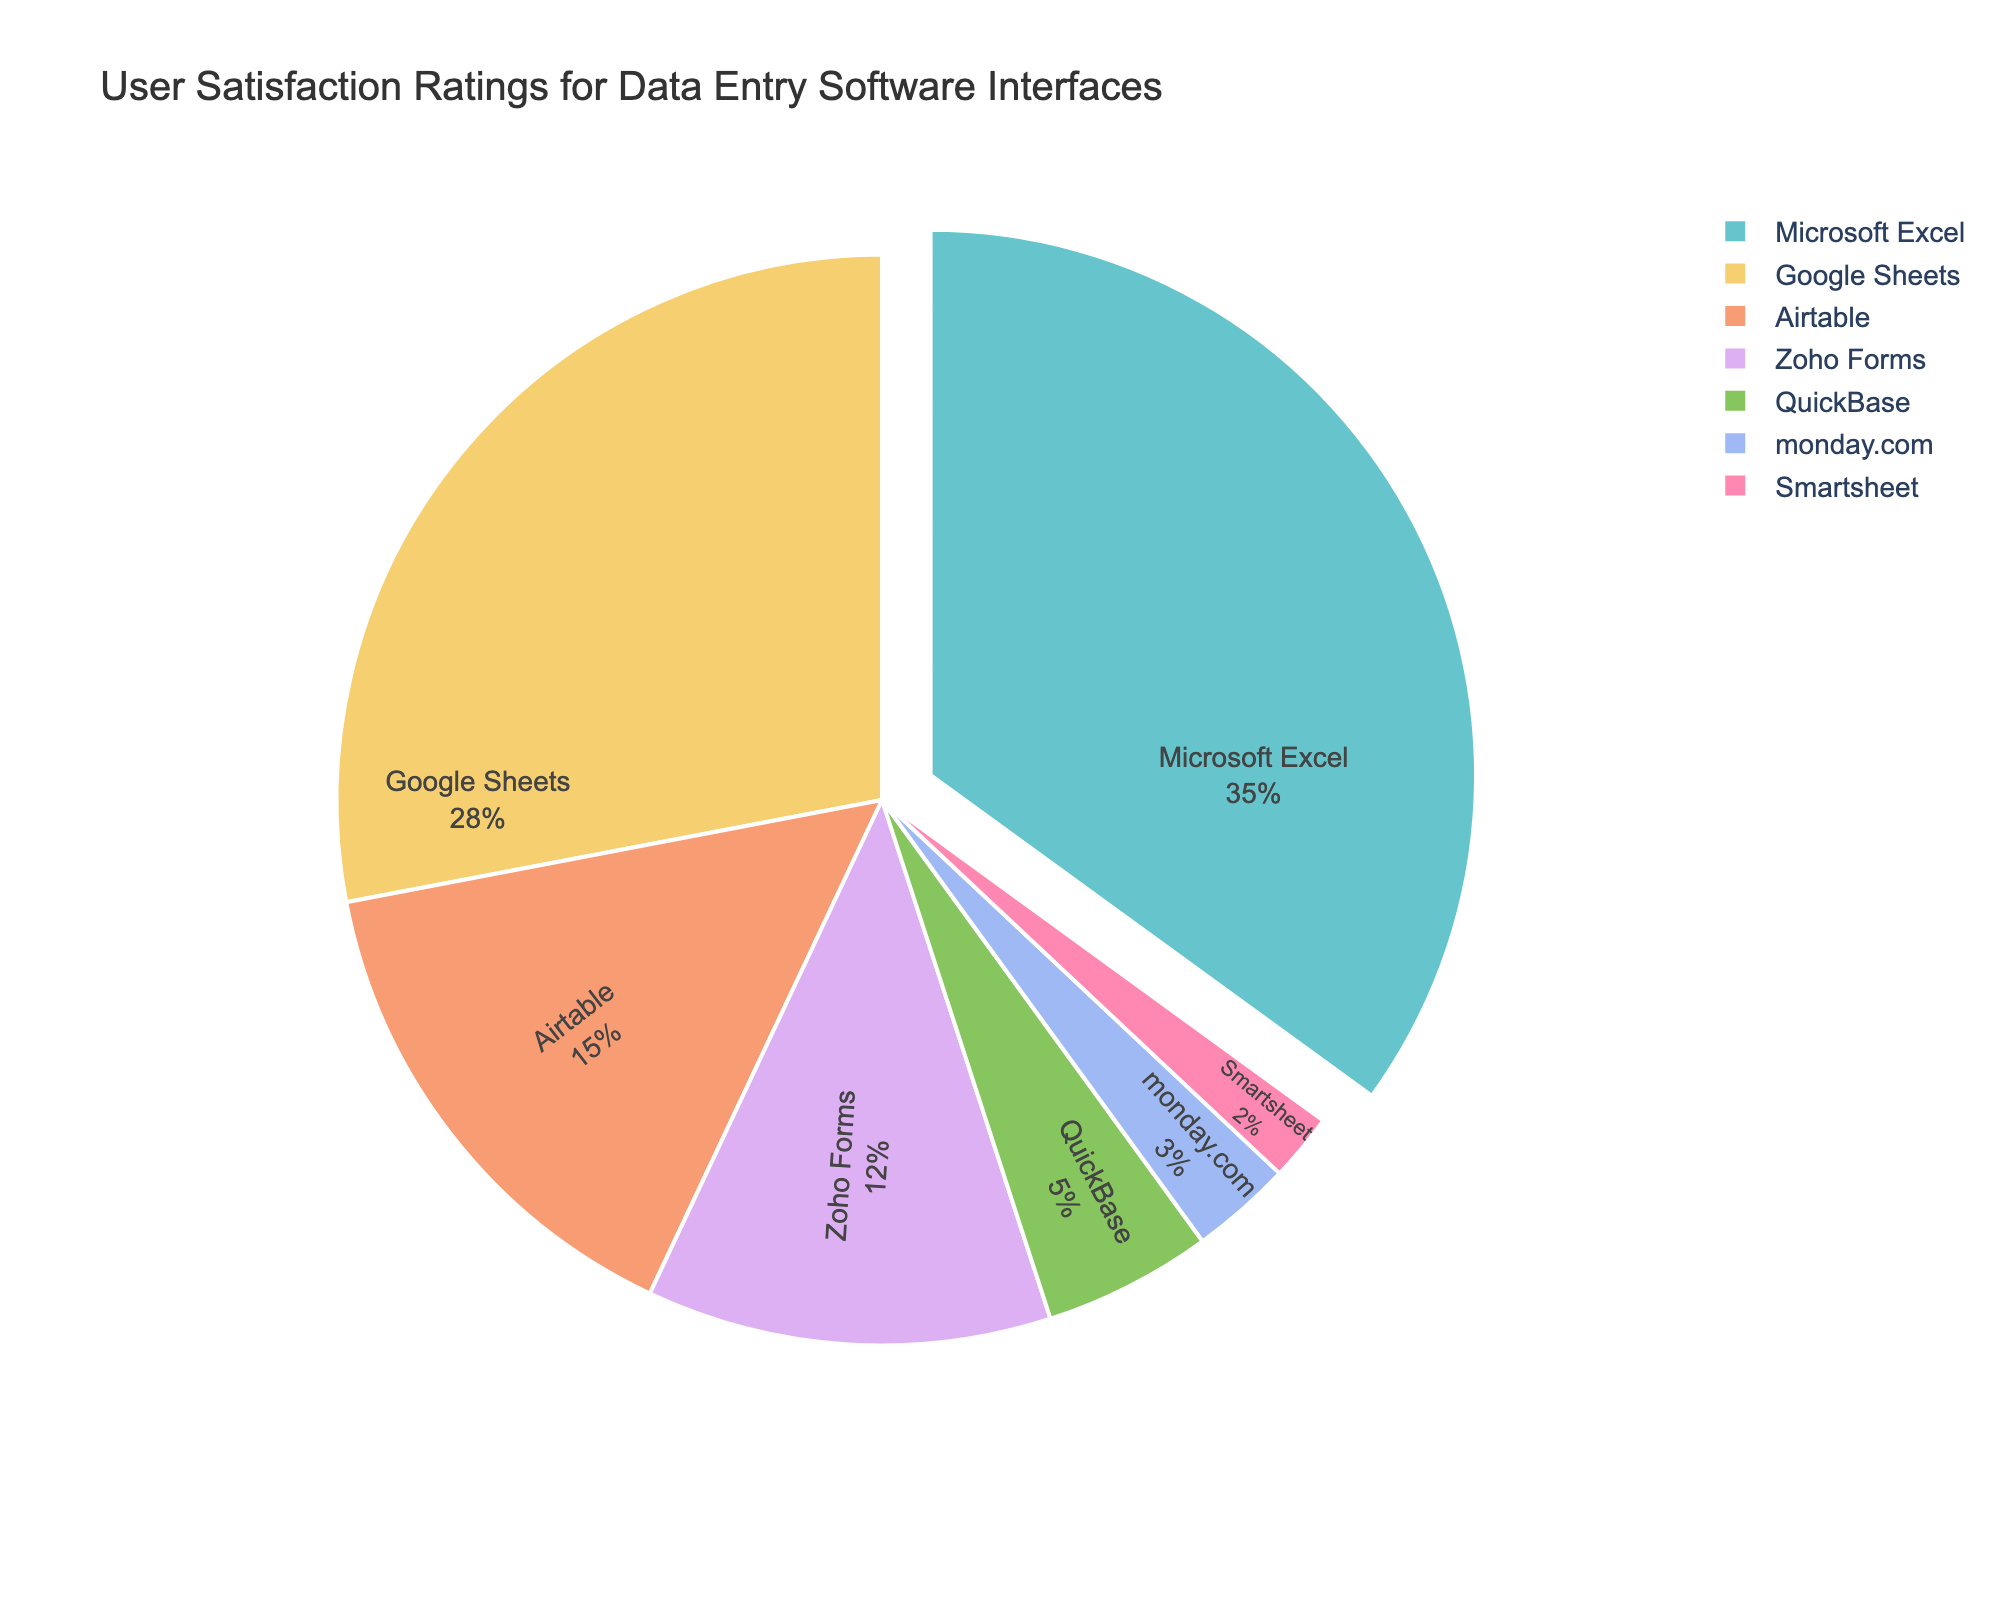What is the software with the highest user satisfaction rating? The chart shows the percentages of user satisfaction ratings for different software. The largest segment of the pie chart corresponds to the software with the highest rating.
Answer: Microsoft Excel Which software has the smallest user satisfaction rating? The chart shows the segments with varying percentages for different software. The smallest segment corresponds to the software with the lowest rating.
Answer: Smartsheet What is the combined satisfaction rating for Google Sheets and Airtable? To find the combined rating, sum the individual satisfaction ratings for Google Sheets and Airtable. Refer to the chart to get these values (28% for Google Sheets and 15% for Airtable). 28 + 15 = 43.
Answer: 43 How does the satisfaction rating for monday.com compare to Zoho Forms? Compare the segments of monday.com and Zoho Forms in terms of their sizes. The satisfaction rating for Zoho Forms (12%) is larger than for monday.com (3%).
Answer: Zoho Forms has a higher satisfaction rating What percentage of the pie chart is made up by the top three software interfaces? The top three software interfaces by satisfaction rating are Microsoft Excel (35%), Google Sheets (28%), and Airtable (15%). Sum these percentages: 35 + 28 + 15 = 78.
Answer: 78% What is the difference in satisfaction ratings between QuickBase and Smartsheet? To find the difference, subtract the satisfaction rating of Smartsheet (2%) from that of QuickBase (5%). 5 - 2 = 3.
Answer: 3 Which software has roughly half the satisfaction rating of Microsoft Excel? Identify the satisfaction rating of Microsoft Excel (35%) and look for a segment that is close to half of this value. QuickBase, with a rating of 5%, is roughly half the rating considering other data points have larger gaps.
Answer: QuickBase Which two software interfaces combined have a higher satisfaction rating than Microsoft Excel alone? Add the ratings of different software pairs and compare to Microsoft Excel's rating (35%). Google Sheets (28%) and Airtable (15%) together is 28 + 15 = 43, which is higher.
Answer: Google Sheets + Airtable Estimate the average satisfaction rating across all the software interfaces shown in the pie chart. Calculate the sum of all satisfaction ratings and divide by the number of software: (35 + 28 + 15 + 12 + 5 + 3 + 2) / 7 = 100 / 7 ≈ 14.3.
Answer: approximately 14.3 How many software interfaces have a satisfaction rating below 10%? Count the segments of the pie chart that are below 10%. Zoho Forms (12%), QuickBase (5%), monday.com (3%), and Smartsheet (2%) are below 10%. This gives four segments.
Answer: 3 